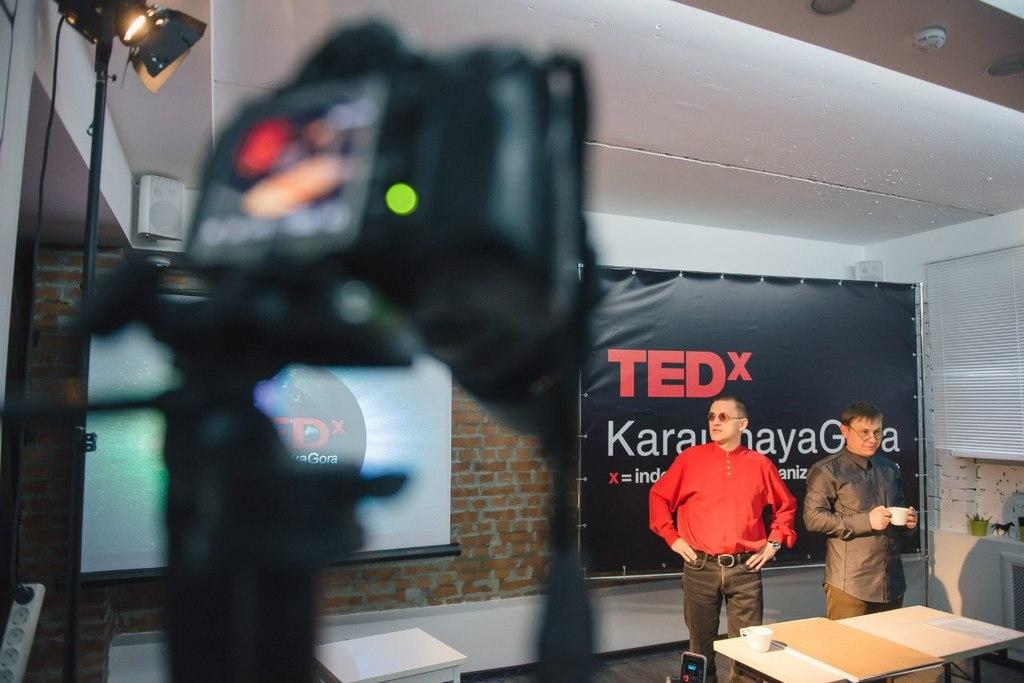What type of structure is visible in the image? There is a brick wall in the image. What can be seen on the wall in the image? There is a screen and lights visible on the wall in the image. What is hanging from the wall in the image? There is a banner hanging from the wall in the image. How many people are present in the image? There are two people standing in the image. What is in front of the people in the image? There is a table in front of the people in the image. What items are on the table in the image? There is a book and a cup on the table in the image. What type of low achiever is depicted on the banner in the image? There is no mention of an achiever, low or otherwise, in the image. The banner simply hangs from the wall. 